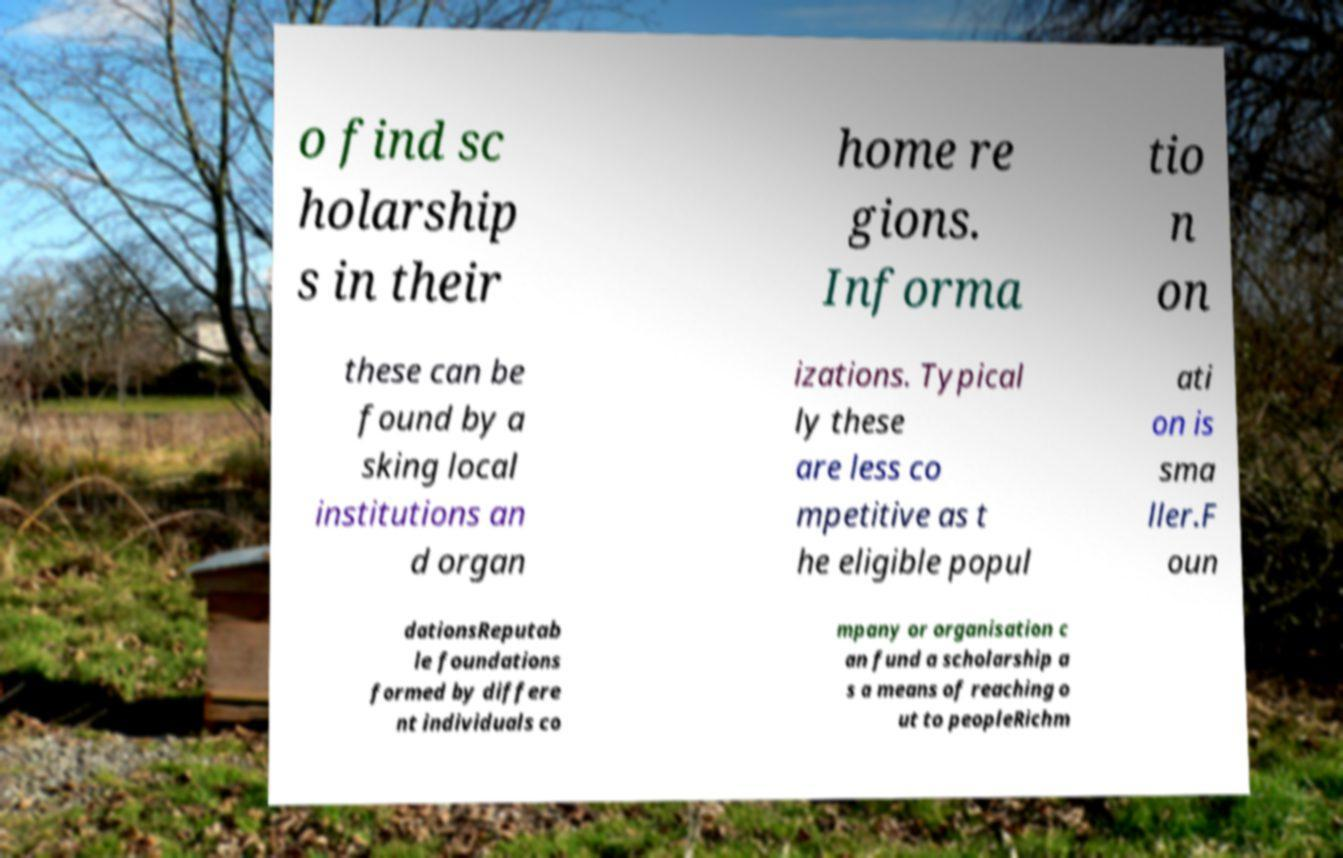For documentation purposes, I need the text within this image transcribed. Could you provide that? o find sc holarship s in their home re gions. Informa tio n on these can be found by a sking local institutions an d organ izations. Typical ly these are less co mpetitive as t he eligible popul ati on is sma ller.F oun dationsReputab le foundations formed by differe nt individuals co mpany or organisation c an fund a scholarship a s a means of reaching o ut to peopleRichm 